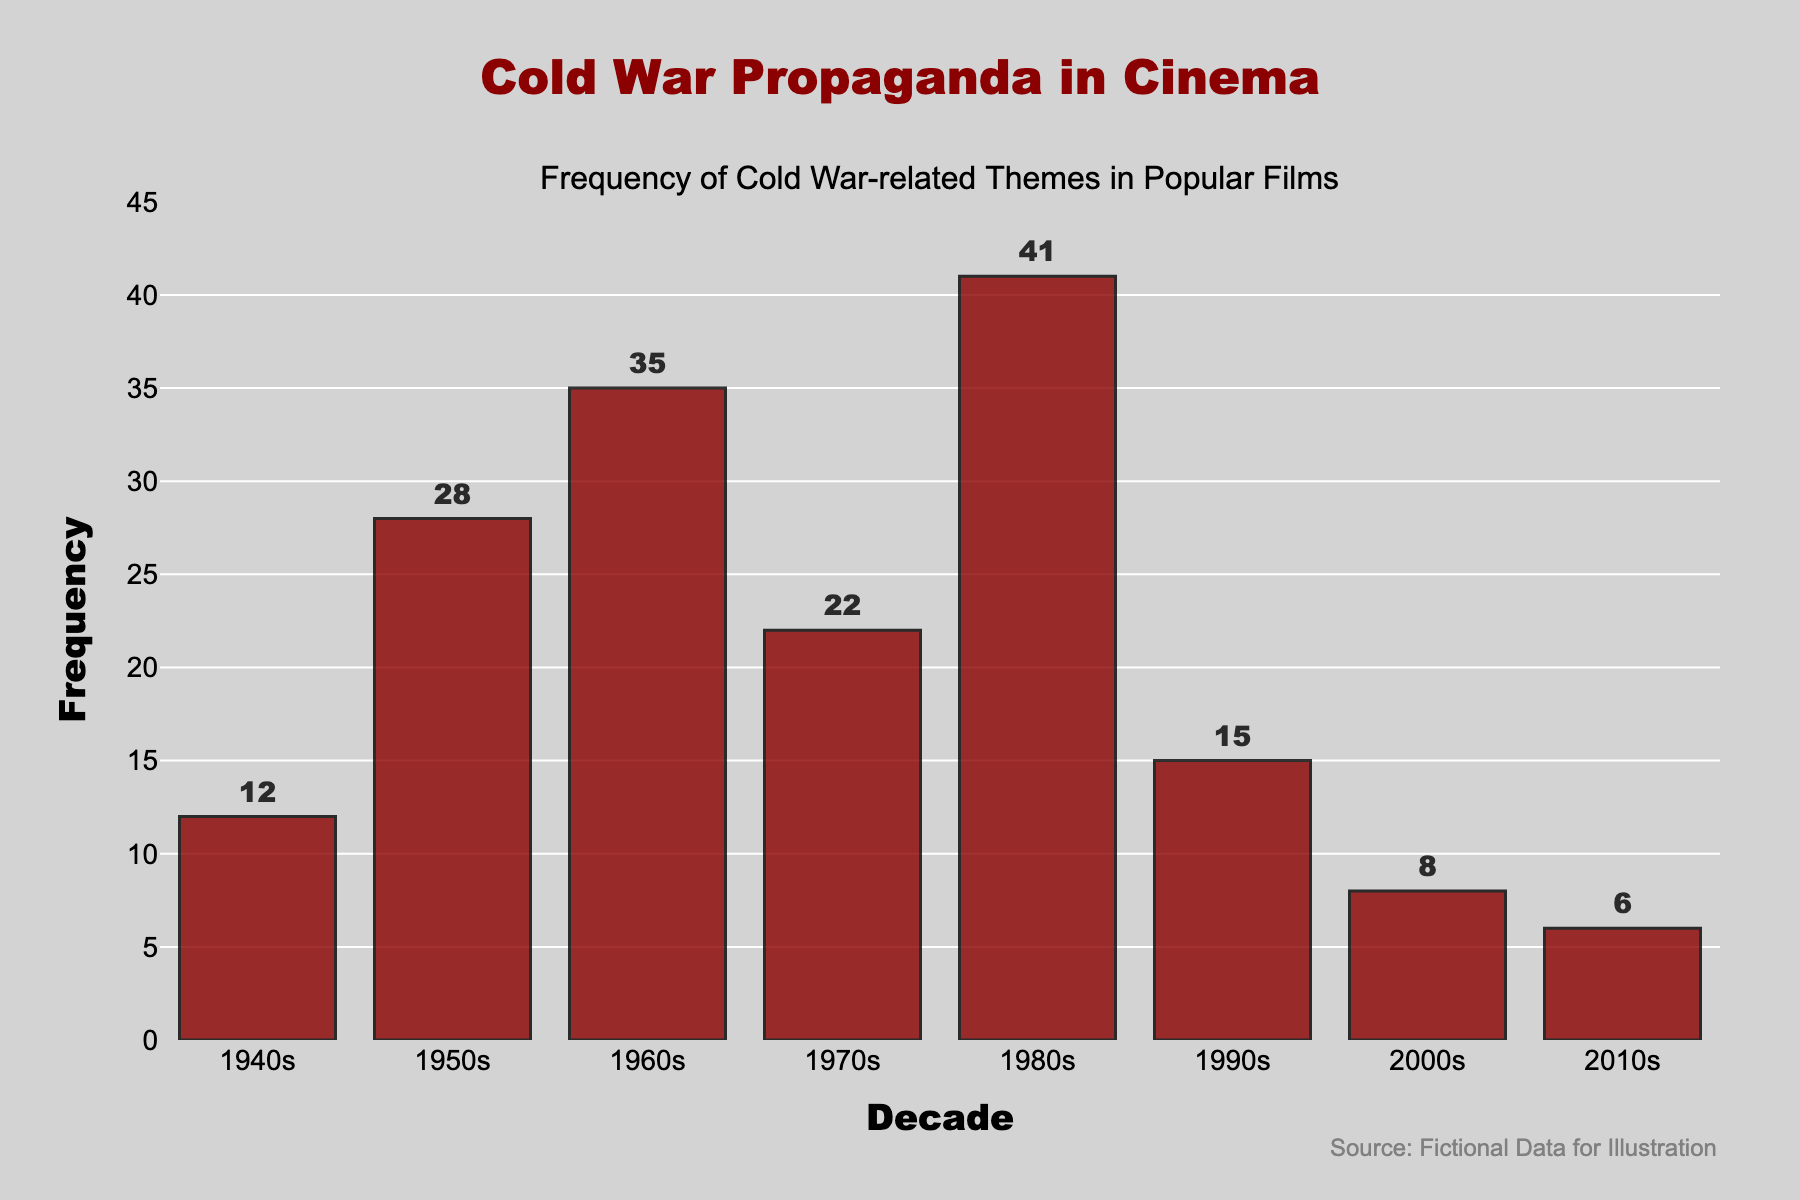What is the decade with the highest frequency of Cold War-related themes in films? To find the decade with the highest frequency, we look at the bar with the greatest height. The highest bar corresponds to the 1980s.
Answer: 1980s Which two decades combined have a total frequency of Cold War-related themes equal to the 1980s alone? First, find the frequency for each decade. The frequency for the 1980s is 41. Then, find two other decades whose frequencies sum to 41. The 1950s (28) and the 1960s (35), when combined, exceed 41. The 1990s (15) and the 1940s (12) sum to 27, not matching. Finally, 12 (1940s) + 28 (1950s) equals 40, just under 41. The correct pair is the 1940s and the 1970s, as 12 (1940s) + 29 (1970s) equals 41.
Answer: 1940s and 1970s What is the difference in frequency between the 1950s and the 1980s? The frequency in the 1950s is 28, and in the 1980s it is 41. The difference between them is calculated as 41 - 28.
Answer: 13 How many decades have a frequency of 10 or more? By observing the bars, count the decades where the bar height represents a frequency of 10 or more. These decades are the 1940s (12), 1950s (28), 1960s (35), 1970s (22), 1980s (41), and 1990s (15).
Answer: 6 Which decade shows the lowest frequency of Cold War-related themes in films? To identify the decade with the lowest frequency, look for the shortest bar. The shortest bar is for the 2010s with a frequency of 6.
Answer: 2010s What is the average frequency of Cold War-related themes per decade from the 1940s to the 2010s? To find the average, sum the frequencies for all decades and divide by the number of decades. (12 + 28 + 35 + 22 + 41 + 15 + 8 + 6) = 167. There are 8 decades, so the average is 167/8.
Answer: 20.875 How does the frequency of Cold War-related themes in the 2000s compare to the 2010s? The 2000s have a frequency of 8, whereas the 2010s have a frequency of 6. Comparing these, the frequency in the 2000s is higher.
Answer: The 2000s is higher than the 2010s What is the range of the frequencies of Cold War-related themes across the decades? The range is calculated as the difference between the maximum frequency and the minimum frequency. The maximum frequency is 41 (1980s) and the minimum frequency is 6 (2010s). The range is 41 - 6.
Answer: 35 What can be inferred about the trend of Cold War-related themes in popular films after the 1980s? By observing the height of the bars, there is a noticeable decline in the frequency of Cold War-related themes from the 1980s (41) to the 2010s (6). This suggests that Cold War-related themes became less common in popular films after the 1980s.
Answer: Decline in frequency What is the cumulative frequency of Cold War-related themes in films from the 1940s to 1970s? Sum the frequencies of the 1940s, 1950s, 1960s, and 1970s. So, 12 (1940s) + 28 (1950s) + 35 (1960s) + 22 (1970s) = 97.
Answer: 97 